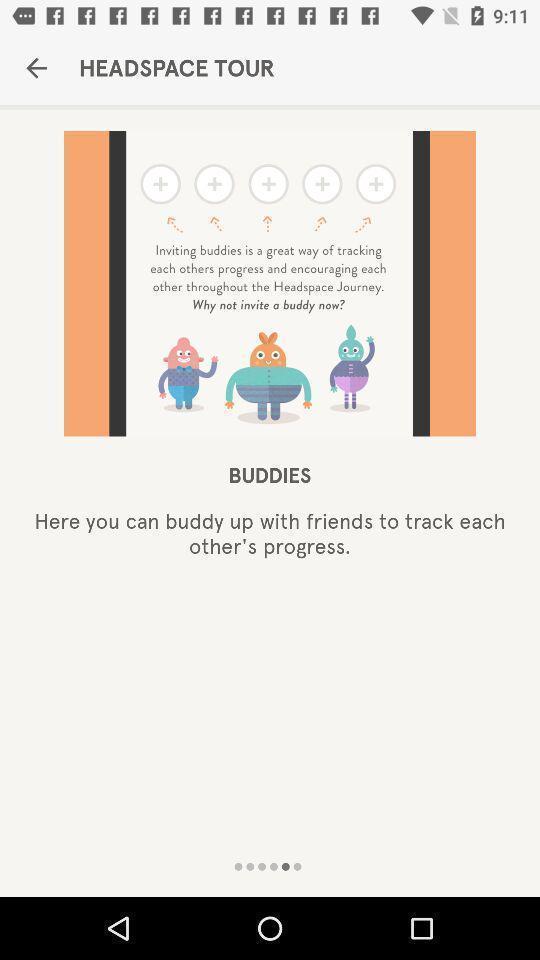Tell me about the visual elements in this screen capture. Page displaying the app tour. 